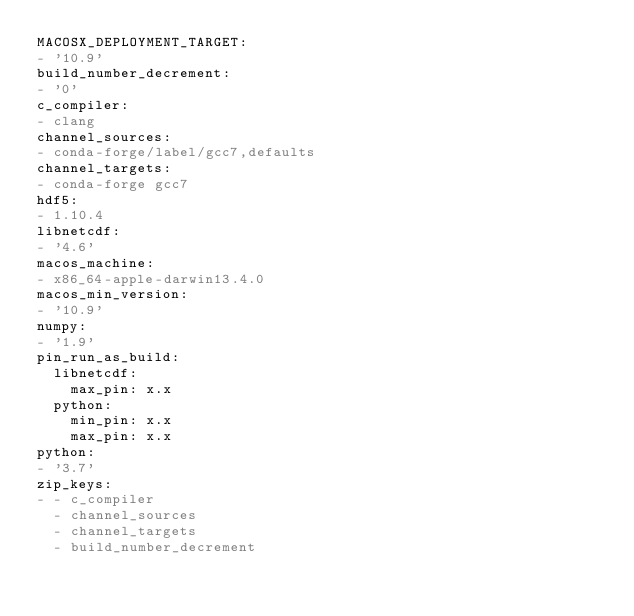<code> <loc_0><loc_0><loc_500><loc_500><_YAML_>MACOSX_DEPLOYMENT_TARGET:
- '10.9'
build_number_decrement:
- '0'
c_compiler:
- clang
channel_sources:
- conda-forge/label/gcc7,defaults
channel_targets:
- conda-forge gcc7
hdf5:
- 1.10.4
libnetcdf:
- '4.6'
macos_machine:
- x86_64-apple-darwin13.4.0
macos_min_version:
- '10.9'
numpy:
- '1.9'
pin_run_as_build:
  libnetcdf:
    max_pin: x.x
  python:
    min_pin: x.x
    max_pin: x.x
python:
- '3.7'
zip_keys:
- - c_compiler
  - channel_sources
  - channel_targets
  - build_number_decrement
</code> 